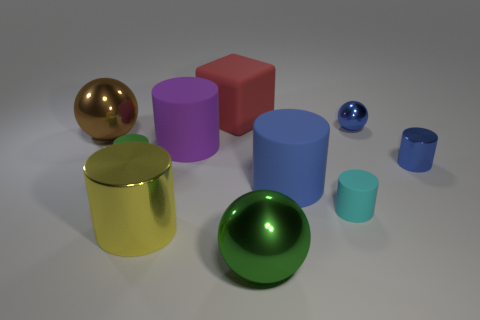What size is the cyan matte cylinder?
Offer a terse response. Small. There is a large blue rubber thing; is it the same shape as the large shiny object that is behind the cyan object?
Offer a terse response. No. There is another small ball that is made of the same material as the brown sphere; what color is it?
Give a very brief answer. Blue. What size is the metallic cylinder to the right of the small cyan cylinder?
Ensure brevity in your answer.  Small. Is the number of objects that are behind the large green shiny thing less than the number of yellow shiny blocks?
Your answer should be compact. No. Do the small shiny sphere and the tiny metallic cylinder have the same color?
Your response must be concise. Yes. Are there any other things that are the same shape as the big red matte object?
Make the answer very short. No. Is the number of blue balls less than the number of big cylinders?
Make the answer very short. Yes. There is a metal object behind the thing on the left side of the tiny green matte cylinder; what is its color?
Your answer should be compact. Blue. There is a large sphere that is behind the tiny matte object on the right side of the large sphere that is on the right side of the red matte block; what is it made of?
Ensure brevity in your answer.  Metal. 